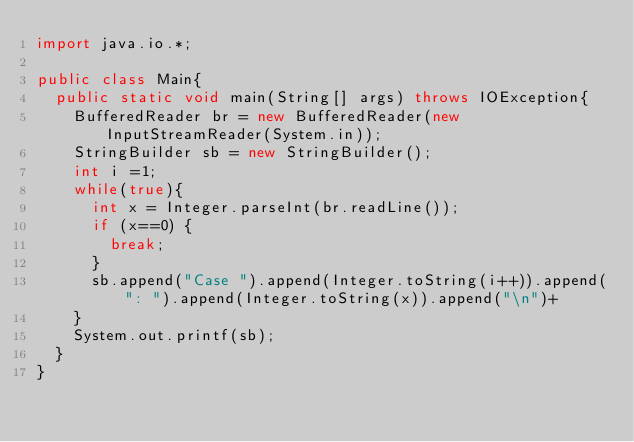Convert code to text. <code><loc_0><loc_0><loc_500><loc_500><_Java_>import java.io.*;

public class Main{
	public static void main(String[] args) throws IOException{
		BufferedReader br = new BufferedReader(new InputStreamReader(System.in));
		StringBuilder sb = new StringBuilder();
		int i =1;
		while(true){
			int x = Integer.parseInt(br.readLine());
			if (x==0) {
				break;
			}
			sb.append("Case ").append(Integer.toString(i++)).append(": ").append(Integer.toString(x)).append("\n")+
		}
		System.out.printf(sb);
	}
}</code> 